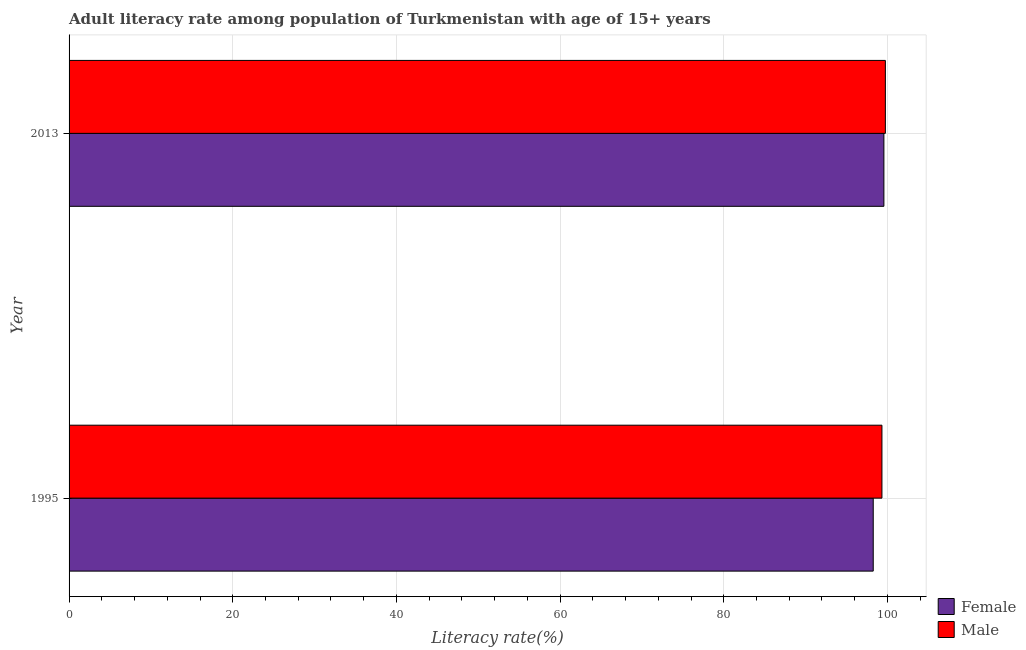What is the male adult literacy rate in 1995?
Offer a very short reply. 99.32. Across all years, what is the maximum male adult literacy rate?
Make the answer very short. 99.75. Across all years, what is the minimum female adult literacy rate?
Your response must be concise. 98.26. What is the total female adult literacy rate in the graph?
Ensure brevity in your answer.  197.83. What is the difference between the female adult literacy rate in 1995 and that in 2013?
Provide a succinct answer. -1.3. What is the difference between the female adult literacy rate in 1995 and the male adult literacy rate in 2013?
Your answer should be compact. -1.48. What is the average male adult literacy rate per year?
Your answer should be compact. 99.53. In the year 1995, what is the difference between the female adult literacy rate and male adult literacy rate?
Your answer should be compact. -1.06. In how many years, is the male adult literacy rate greater than 96 %?
Provide a succinct answer. 2. What is the ratio of the female adult literacy rate in 1995 to that in 2013?
Provide a succinct answer. 0.99. Is the male adult literacy rate in 1995 less than that in 2013?
Ensure brevity in your answer.  Yes. Is the difference between the female adult literacy rate in 1995 and 2013 greater than the difference between the male adult literacy rate in 1995 and 2013?
Make the answer very short. No. What does the 1st bar from the bottom in 2013 represents?
Your answer should be very brief. Female. How many years are there in the graph?
Your response must be concise. 2. What is the difference between two consecutive major ticks on the X-axis?
Your response must be concise. 20. Does the graph contain grids?
Ensure brevity in your answer.  Yes. Where does the legend appear in the graph?
Provide a short and direct response. Bottom right. What is the title of the graph?
Make the answer very short. Adult literacy rate among population of Turkmenistan with age of 15+ years. Does "Unregistered firms" appear as one of the legend labels in the graph?
Make the answer very short. No. What is the label or title of the X-axis?
Your response must be concise. Literacy rate(%). What is the label or title of the Y-axis?
Your answer should be very brief. Year. What is the Literacy rate(%) of Female in 1995?
Give a very brief answer. 98.26. What is the Literacy rate(%) in Male in 1995?
Offer a very short reply. 99.32. What is the Literacy rate(%) in Female in 2013?
Keep it short and to the point. 99.56. What is the Literacy rate(%) of Male in 2013?
Offer a very short reply. 99.75. Across all years, what is the maximum Literacy rate(%) of Female?
Your answer should be very brief. 99.56. Across all years, what is the maximum Literacy rate(%) of Male?
Provide a short and direct response. 99.75. Across all years, what is the minimum Literacy rate(%) in Female?
Your response must be concise. 98.26. Across all years, what is the minimum Literacy rate(%) of Male?
Give a very brief answer. 99.32. What is the total Literacy rate(%) in Female in the graph?
Make the answer very short. 197.83. What is the total Literacy rate(%) in Male in the graph?
Give a very brief answer. 199.07. What is the difference between the Literacy rate(%) of Female in 1995 and that in 2013?
Your answer should be very brief. -1.3. What is the difference between the Literacy rate(%) of Male in 1995 and that in 2013?
Your answer should be compact. -0.42. What is the difference between the Literacy rate(%) of Female in 1995 and the Literacy rate(%) of Male in 2013?
Keep it short and to the point. -1.48. What is the average Literacy rate(%) in Female per year?
Provide a succinct answer. 98.91. What is the average Literacy rate(%) of Male per year?
Ensure brevity in your answer.  99.54. In the year 1995, what is the difference between the Literacy rate(%) of Female and Literacy rate(%) of Male?
Offer a very short reply. -1.06. In the year 2013, what is the difference between the Literacy rate(%) in Female and Literacy rate(%) in Male?
Provide a succinct answer. -0.18. What is the ratio of the Literacy rate(%) in Female in 1995 to that in 2013?
Give a very brief answer. 0.99. What is the ratio of the Literacy rate(%) in Male in 1995 to that in 2013?
Your answer should be very brief. 1. What is the difference between the highest and the second highest Literacy rate(%) in Female?
Keep it short and to the point. 1.3. What is the difference between the highest and the second highest Literacy rate(%) in Male?
Keep it short and to the point. 0.42. What is the difference between the highest and the lowest Literacy rate(%) in Female?
Offer a very short reply. 1.3. What is the difference between the highest and the lowest Literacy rate(%) of Male?
Make the answer very short. 0.42. 